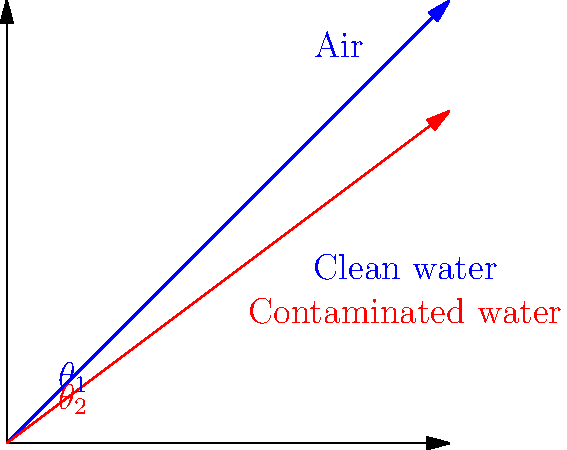As part of a water quality assessment in rural Buenos Aires, you're analyzing the refraction of light through different water samples. A laser beam enters a water sample at an angle of 45° to the normal. If the refractive index of clean water is 1.33 and that of slightly contaminated water is 1.36, what is the difference in the angle of refraction between the two samples (in degrees, rounded to one decimal place)? To solve this problem, we'll use Snell's law and follow these steps:

1) Snell's law states: $n_1 \sin(\theta_1) = n_2 \sin(\theta_2)$

2) For clean water:
   $1 \cdot \sin(45°) = 1.33 \cdot \sin(\theta_{clean})$
   $\sin(\theta_{clean}) = \frac{\sin(45°)}{1.33}$
   $\theta_{clean} = \arcsin(\frac{\sin(45°)}{1.33}) \approx 32.0°$

3) For contaminated water:
   $1 \cdot \sin(45°) = 1.36 \cdot \sin(\theta_{contaminated})$
   $\sin(\theta_{contaminated}) = \frac{\sin(45°)}{1.36}$
   $\theta_{contaminated} = \arcsin(\frac{\sin(45°)}{1.36}) \approx 31.3°$

4) Calculate the difference:
   $\Delta\theta = \theta_{clean} - \theta_{contaminated} \approx 32.0° - 31.3° = 0.7°$

5) Rounding to one decimal place: 0.7°
Answer: 0.7° 